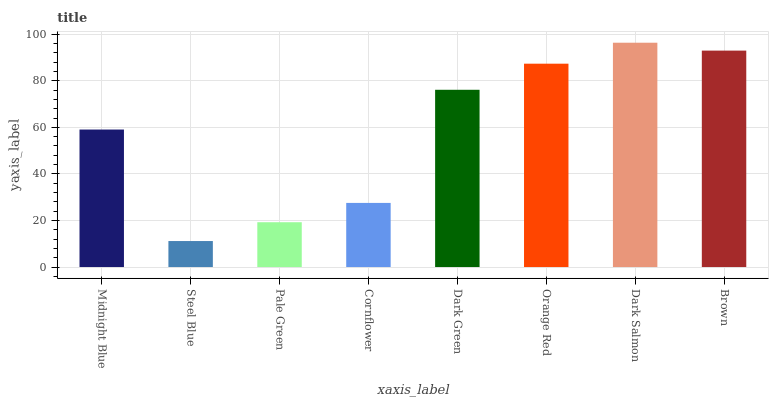Is Pale Green the minimum?
Answer yes or no. No. Is Pale Green the maximum?
Answer yes or no. No. Is Pale Green greater than Steel Blue?
Answer yes or no. Yes. Is Steel Blue less than Pale Green?
Answer yes or no. Yes. Is Steel Blue greater than Pale Green?
Answer yes or no. No. Is Pale Green less than Steel Blue?
Answer yes or no. No. Is Dark Green the high median?
Answer yes or no. Yes. Is Midnight Blue the low median?
Answer yes or no. Yes. Is Orange Red the high median?
Answer yes or no. No. Is Brown the low median?
Answer yes or no. No. 